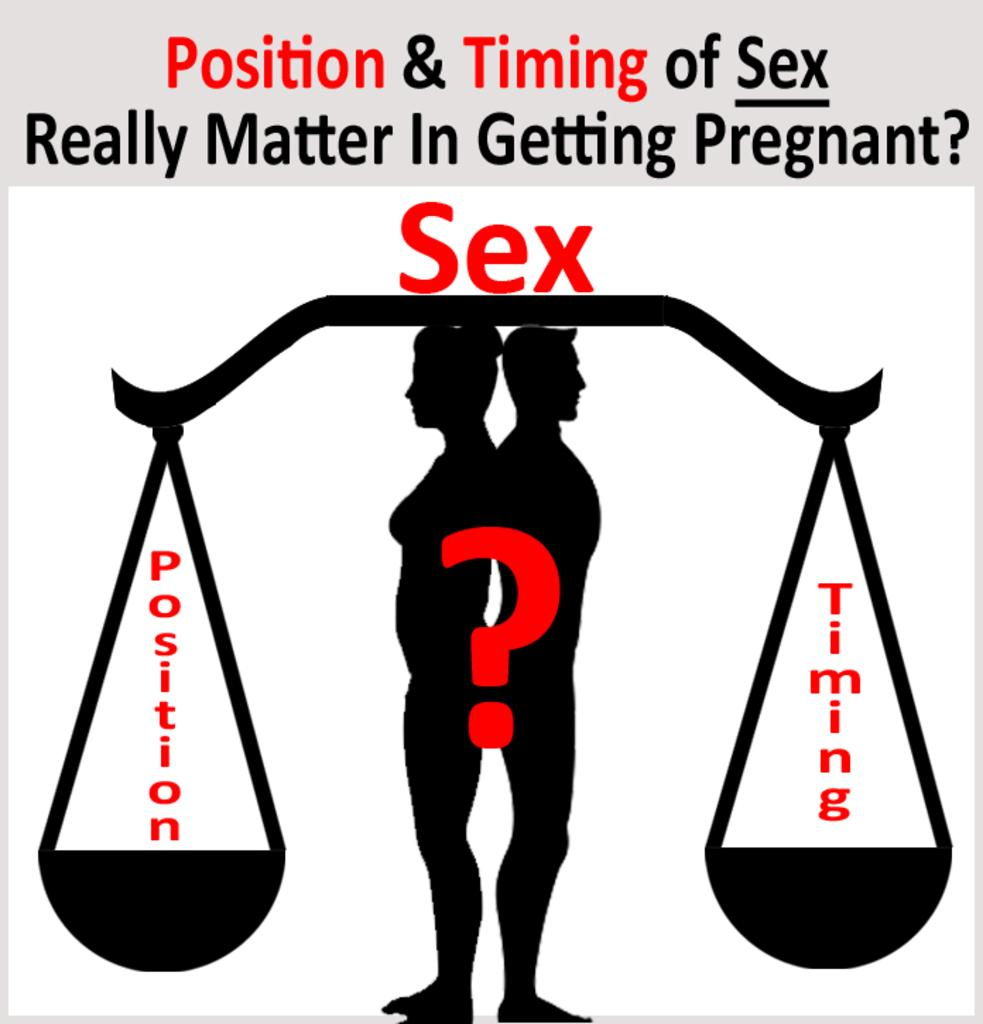<image>
Give a short and clear explanation of the subsequent image. A man and woman standing underneath a scale with the word sex on top. 